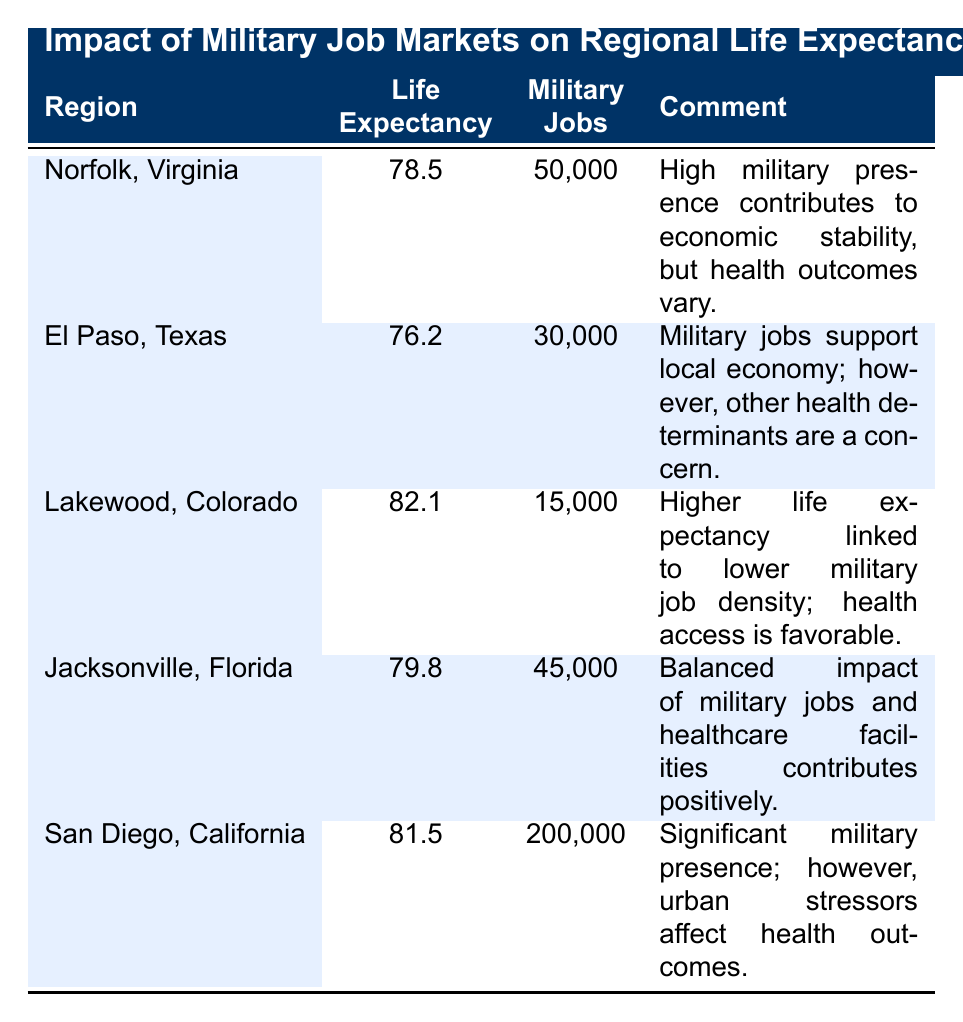What is the life expectancy for San Diego, California? The table indicates that for San Diego, California, the life expectancy is explicitly listed as 81.5.
Answer: 81.5 Which region has the highest life expectancy among those listed? By comparing the life expectancy values from the table, Lakewood, Colorado has the highest life expectancy at 82.1.
Answer: Lakewood, Colorado How many military jobs are there in El Paso, Texas? The table shows that El Paso, Texas has a total of 30,000 military jobs reported in the military jobs column.
Answer: 30,000 Is the life expectancy in Jacksonville, Florida greater than that in Norfolk, Virginia? In the table, Jacksonville, Florida has a life expectancy of 79.8, while Norfolk, Virginia has 78.5. Since 79.8 is greater than 78.5, the answer is yes.
Answer: Yes What is the average life expectancy of regions with more than 40,000 military jobs? The regions with more than 40,000 military jobs are Norfolk (78.5), Jacksonville (79.8), and San Diego (81.5). First, we sum these life expectancies: 78.5 + 79.8 + 81.5 = 239.8. Since there are 3 regions, we divide by 3 to find the average: 239.8 / 3 = approximately 79.93.
Answer: Approximately 79.93 How do military job numbers compare in Lakewood, Colorado and San Diego, California? The table shows Lakewood, Colorado has 15,000 military jobs and San Diego, California has 200,000 military jobs. Since 200,000 is significantly greater than 15,000, it clearly indicates San Diego has many more military jobs.
Answer: San Diego has more military jobs Is there a correlation between the number of military jobs and life expectancy in the specified regions? To establish correlation, we compare the military jobs and life expectancy in the regions. Observing the data, San Diego has the most military jobs (200,000) but a slightly lower life expectancy than Lakewood (82.1), which has only 15,000 military jobs. This irregularity suggests that the correlation is not straightforward, indicating that other factors may influence life expectancy, rather than solely the number of military jobs.
Answer: No clear correlation 